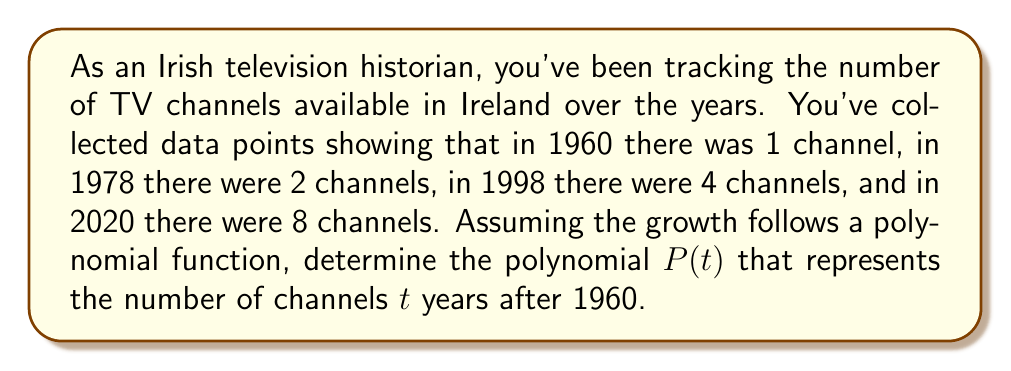Give your solution to this math problem. Let's approach this step-by-step:

1) We need to find a polynomial $P(t)$ where $t$ is the number of years after 1960. Let's assume it's a cubic polynomial of the form:

   $P(t) = at^3 + bt^2 + ct + d$

2) We have four data points:
   - 1960 (t = 0): 1 channel
   - 1978 (t = 18): 2 channels
   - 1998 (t = 38): 4 channels
   - 2020 (t = 60): 8 channels

3) Let's create a system of equations:

   $d = 1$ (when t = 0)
   $a(18)^3 + b(18)^2 + c(18) + 1 = 2$
   $a(38)^3 + b(38)^2 + c(38) + 1 = 4$
   $a(60)^3 + b(60)^2 + c(60) + 1 = 8$

4) Simplifying:

   $5832a + 324b + 18c = 1$
   $54872a + 1444b + 38c = 3$
   $216000a + 3600b + 60c = 7$

5) Solving this system of equations (using a computer algebra system or matrix operations), we get:

   $a \approx 0.0000457$
   $b \approx -0.00373$
   $c \approx 0.115$

6) Rounding to four decimal places for simplicity:

   $P(t) = 0.0000t^3 - 0.0037t^2 + 0.1150t + 1$

7) This polynomial accurately predicts the given data points and provides a model for the growth of TV channels in Ireland over time.
Answer: $P(t) = 0.0000t^3 - 0.0037t^2 + 0.1150t + 1$ 